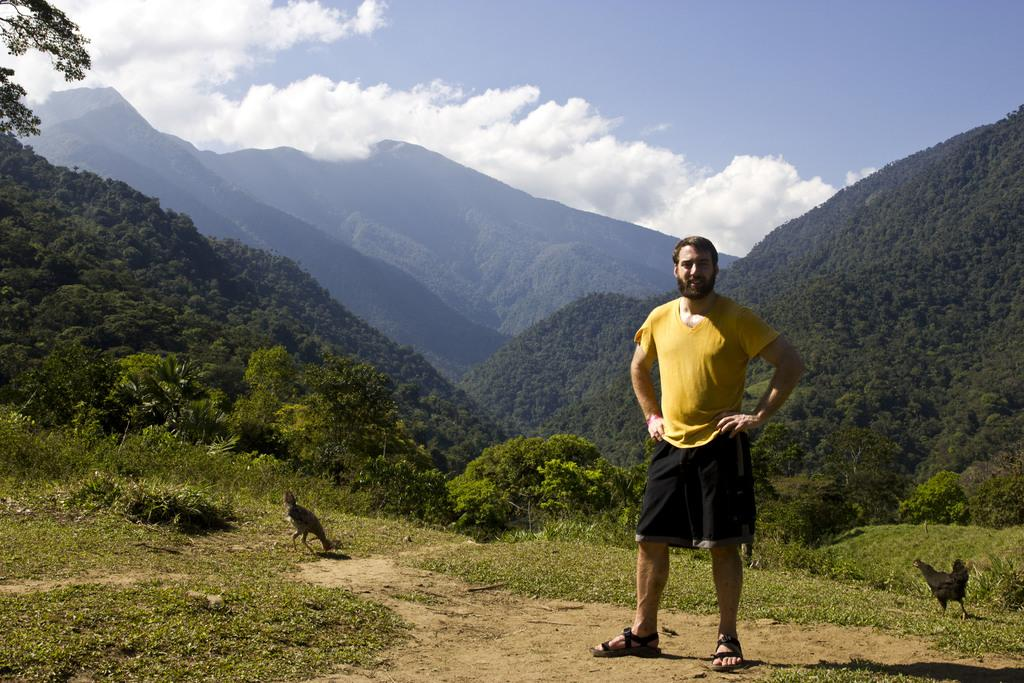Who is present in the image? There is a man in the image. What is on the ground in the image? There is grass on the ground in the image. What type of animals can be seen in the image? There are hens in the image. What can be seen in the background of the image? There are hills and trees in the background of the image. What is visible in the sky in the image? The sky is visible in the image, and clouds are present. What type of leaf is being used as a horn by the man in the image? There is no leaf or horn present in the image; the man is not depicted using any such objects. 